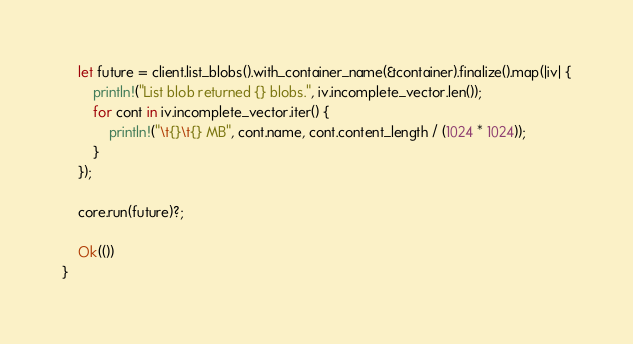<code> <loc_0><loc_0><loc_500><loc_500><_Rust_>    let future = client.list_blobs().with_container_name(&container).finalize().map(|iv| {
        println!("List blob returned {} blobs.", iv.incomplete_vector.len());
        for cont in iv.incomplete_vector.iter() {
            println!("\t{}\t{} MB", cont.name, cont.content_length / (1024 * 1024));
        }
    });

    core.run(future)?;

    Ok(())
}
</code> 